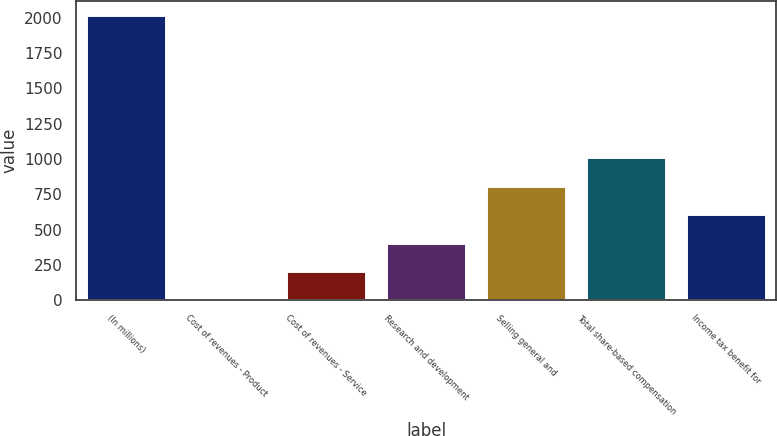Convert chart to OTSL. <chart><loc_0><loc_0><loc_500><loc_500><bar_chart><fcel>(In millions)<fcel>Cost of revenues - Product<fcel>Cost of revenues - Service<fcel>Research and development<fcel>Selling general and<fcel>Total share-based compensation<fcel>Income tax benefit for<nl><fcel>2016<fcel>4.2<fcel>205.38<fcel>406.56<fcel>808.92<fcel>1010.1<fcel>607.74<nl></chart> 